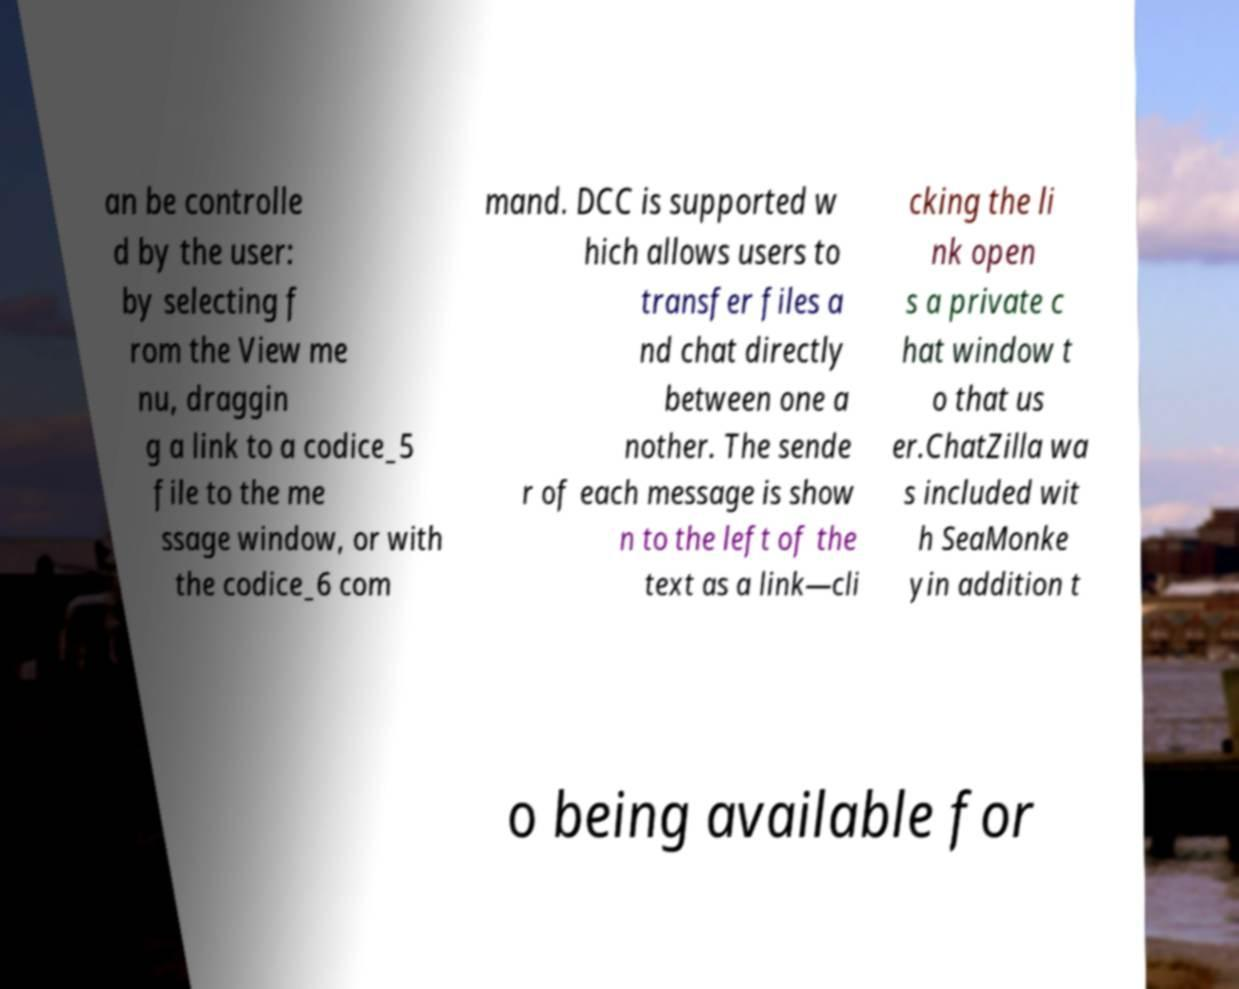What messages or text are displayed in this image? I need them in a readable, typed format. an be controlle d by the user: by selecting f rom the View me nu, draggin g a link to a codice_5 file to the me ssage window, or with the codice_6 com mand. DCC is supported w hich allows users to transfer files a nd chat directly between one a nother. The sende r of each message is show n to the left of the text as a link—cli cking the li nk open s a private c hat window t o that us er.ChatZilla wa s included wit h SeaMonke yin addition t o being available for 